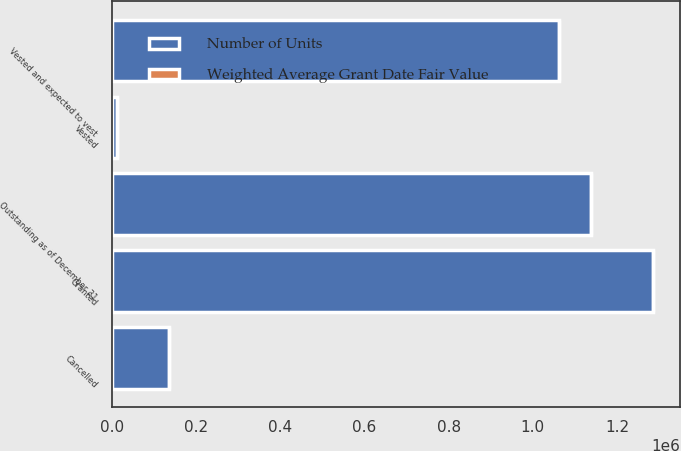Convert chart. <chart><loc_0><loc_0><loc_500><loc_500><stacked_bar_chart><ecel><fcel>Granted<fcel>Vested<fcel>Cancelled<fcel>Outstanding as of December 31<fcel>Vested and expected to vest<nl><fcel>Number of Units<fcel>1.28581e+06<fcel>11440<fcel>136100<fcel>1.13827e+06<fcel>1.06261e+06<nl><fcel>Weighted Average Grant Date Fair Value<fcel>37.26<fcel>37.7<fcel>37.8<fcel>37.19<fcel>37.17<nl></chart> 